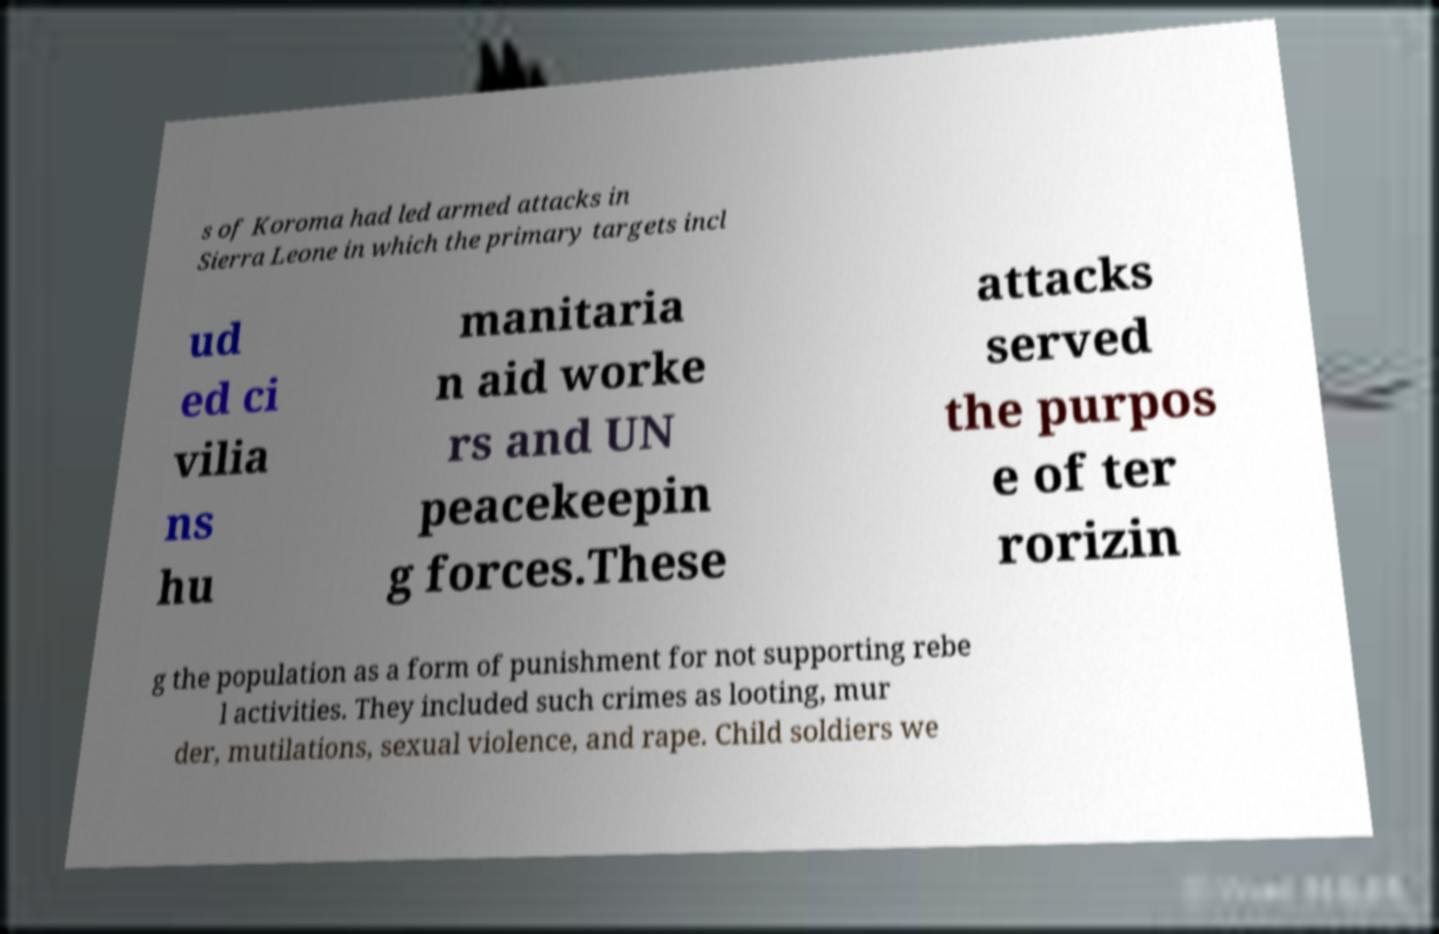Can you read and provide the text displayed in the image?This photo seems to have some interesting text. Can you extract and type it out for me? s of Koroma had led armed attacks in Sierra Leone in which the primary targets incl ud ed ci vilia ns hu manitaria n aid worke rs and UN peacekeepin g forces.These attacks served the purpos e of ter rorizin g the population as a form of punishment for not supporting rebe l activities. They included such crimes as looting, mur der, mutilations, sexual violence, and rape. Child soldiers we 